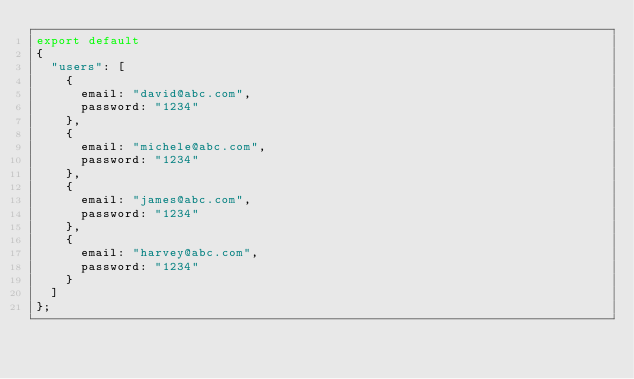Convert code to text. <code><loc_0><loc_0><loc_500><loc_500><_TypeScript_>export default
{
	"users": [
		{
			email: "david@abc.com",
			password: "1234"
		},
		{
			email: "michele@abc.com",
			password: "1234"
		},
		{
			email: "james@abc.com",
			password: "1234"
		},
		{
			email: "harvey@abc.com",
			password: "1234"
		}
	]
};
</code> 